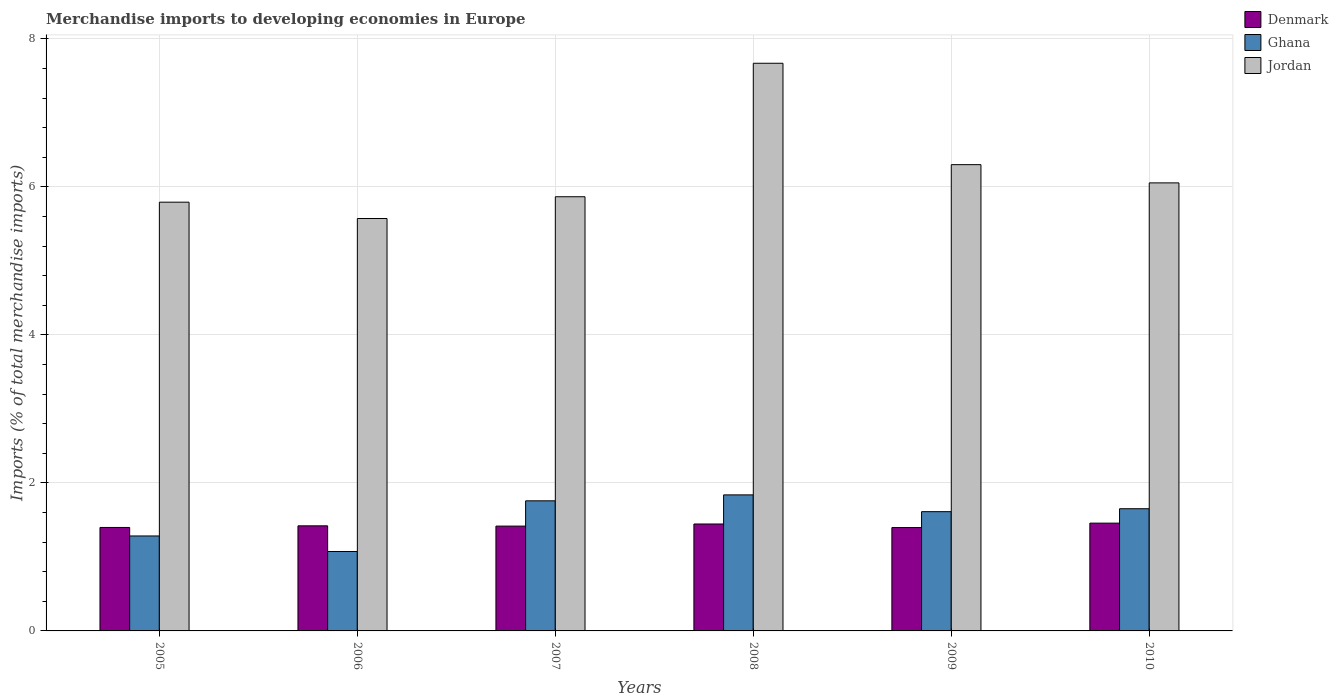How many different coloured bars are there?
Offer a very short reply. 3. How many groups of bars are there?
Provide a succinct answer. 6. In how many cases, is the number of bars for a given year not equal to the number of legend labels?
Ensure brevity in your answer.  0. What is the percentage total merchandise imports in Ghana in 2007?
Ensure brevity in your answer.  1.76. Across all years, what is the maximum percentage total merchandise imports in Denmark?
Provide a succinct answer. 1.46. Across all years, what is the minimum percentage total merchandise imports in Jordan?
Ensure brevity in your answer.  5.57. In which year was the percentage total merchandise imports in Ghana maximum?
Provide a short and direct response. 2008. What is the total percentage total merchandise imports in Jordan in the graph?
Your answer should be compact. 37.26. What is the difference between the percentage total merchandise imports in Denmark in 2006 and that in 2009?
Offer a terse response. 0.02. What is the difference between the percentage total merchandise imports in Jordan in 2007 and the percentage total merchandise imports in Denmark in 2009?
Give a very brief answer. 4.47. What is the average percentage total merchandise imports in Denmark per year?
Provide a succinct answer. 1.42. In the year 2006, what is the difference between the percentage total merchandise imports in Jordan and percentage total merchandise imports in Denmark?
Your answer should be compact. 4.15. What is the ratio of the percentage total merchandise imports in Denmark in 2007 to that in 2010?
Provide a short and direct response. 0.97. Is the percentage total merchandise imports in Jordan in 2005 less than that in 2010?
Keep it short and to the point. Yes. Is the difference between the percentage total merchandise imports in Jordan in 2009 and 2010 greater than the difference between the percentage total merchandise imports in Denmark in 2009 and 2010?
Offer a terse response. Yes. What is the difference between the highest and the second highest percentage total merchandise imports in Denmark?
Provide a short and direct response. 0.01. What is the difference between the highest and the lowest percentage total merchandise imports in Jordan?
Your answer should be compact. 2.1. In how many years, is the percentage total merchandise imports in Denmark greater than the average percentage total merchandise imports in Denmark taken over all years?
Give a very brief answer. 2. What does the 3rd bar from the left in 2006 represents?
Offer a terse response. Jordan. What does the 1st bar from the right in 2009 represents?
Your response must be concise. Jordan. How many bars are there?
Provide a succinct answer. 18. Are all the bars in the graph horizontal?
Give a very brief answer. No. How many years are there in the graph?
Provide a short and direct response. 6. What is the difference between two consecutive major ticks on the Y-axis?
Offer a terse response. 2. Does the graph contain grids?
Offer a terse response. Yes. Where does the legend appear in the graph?
Your response must be concise. Top right. How are the legend labels stacked?
Provide a short and direct response. Vertical. What is the title of the graph?
Ensure brevity in your answer.  Merchandise imports to developing economies in Europe. Does "Sub-Saharan Africa (all income levels)" appear as one of the legend labels in the graph?
Provide a succinct answer. No. What is the label or title of the Y-axis?
Provide a succinct answer. Imports (% of total merchandise imports). What is the Imports (% of total merchandise imports) in Denmark in 2005?
Your answer should be very brief. 1.4. What is the Imports (% of total merchandise imports) in Ghana in 2005?
Offer a very short reply. 1.28. What is the Imports (% of total merchandise imports) of Jordan in 2005?
Provide a succinct answer. 5.79. What is the Imports (% of total merchandise imports) in Denmark in 2006?
Ensure brevity in your answer.  1.42. What is the Imports (% of total merchandise imports) of Ghana in 2006?
Your answer should be compact. 1.07. What is the Imports (% of total merchandise imports) in Jordan in 2006?
Provide a succinct answer. 5.57. What is the Imports (% of total merchandise imports) in Denmark in 2007?
Make the answer very short. 1.42. What is the Imports (% of total merchandise imports) in Ghana in 2007?
Your answer should be very brief. 1.76. What is the Imports (% of total merchandise imports) in Jordan in 2007?
Give a very brief answer. 5.87. What is the Imports (% of total merchandise imports) in Denmark in 2008?
Keep it short and to the point. 1.44. What is the Imports (% of total merchandise imports) of Ghana in 2008?
Provide a succinct answer. 1.84. What is the Imports (% of total merchandise imports) of Jordan in 2008?
Ensure brevity in your answer.  7.67. What is the Imports (% of total merchandise imports) in Denmark in 2009?
Give a very brief answer. 1.4. What is the Imports (% of total merchandise imports) of Ghana in 2009?
Keep it short and to the point. 1.61. What is the Imports (% of total merchandise imports) of Jordan in 2009?
Ensure brevity in your answer.  6.3. What is the Imports (% of total merchandise imports) in Denmark in 2010?
Give a very brief answer. 1.46. What is the Imports (% of total merchandise imports) of Ghana in 2010?
Your answer should be very brief. 1.65. What is the Imports (% of total merchandise imports) in Jordan in 2010?
Your answer should be compact. 6.05. Across all years, what is the maximum Imports (% of total merchandise imports) of Denmark?
Provide a short and direct response. 1.46. Across all years, what is the maximum Imports (% of total merchandise imports) of Ghana?
Keep it short and to the point. 1.84. Across all years, what is the maximum Imports (% of total merchandise imports) of Jordan?
Keep it short and to the point. 7.67. Across all years, what is the minimum Imports (% of total merchandise imports) of Denmark?
Offer a very short reply. 1.4. Across all years, what is the minimum Imports (% of total merchandise imports) in Ghana?
Provide a short and direct response. 1.07. Across all years, what is the minimum Imports (% of total merchandise imports) of Jordan?
Provide a short and direct response. 5.57. What is the total Imports (% of total merchandise imports) in Denmark in the graph?
Provide a succinct answer. 8.53. What is the total Imports (% of total merchandise imports) in Ghana in the graph?
Offer a very short reply. 9.22. What is the total Imports (% of total merchandise imports) in Jordan in the graph?
Your answer should be very brief. 37.26. What is the difference between the Imports (% of total merchandise imports) of Denmark in 2005 and that in 2006?
Provide a succinct answer. -0.02. What is the difference between the Imports (% of total merchandise imports) in Ghana in 2005 and that in 2006?
Provide a succinct answer. 0.21. What is the difference between the Imports (% of total merchandise imports) in Jordan in 2005 and that in 2006?
Make the answer very short. 0.22. What is the difference between the Imports (% of total merchandise imports) in Denmark in 2005 and that in 2007?
Ensure brevity in your answer.  -0.02. What is the difference between the Imports (% of total merchandise imports) in Ghana in 2005 and that in 2007?
Your response must be concise. -0.47. What is the difference between the Imports (% of total merchandise imports) of Jordan in 2005 and that in 2007?
Ensure brevity in your answer.  -0.07. What is the difference between the Imports (% of total merchandise imports) in Denmark in 2005 and that in 2008?
Your answer should be compact. -0.05. What is the difference between the Imports (% of total merchandise imports) of Ghana in 2005 and that in 2008?
Give a very brief answer. -0.56. What is the difference between the Imports (% of total merchandise imports) of Jordan in 2005 and that in 2008?
Offer a very short reply. -1.88. What is the difference between the Imports (% of total merchandise imports) of Denmark in 2005 and that in 2009?
Your answer should be very brief. 0. What is the difference between the Imports (% of total merchandise imports) of Ghana in 2005 and that in 2009?
Provide a short and direct response. -0.33. What is the difference between the Imports (% of total merchandise imports) of Jordan in 2005 and that in 2009?
Ensure brevity in your answer.  -0.51. What is the difference between the Imports (% of total merchandise imports) in Denmark in 2005 and that in 2010?
Provide a short and direct response. -0.06. What is the difference between the Imports (% of total merchandise imports) in Ghana in 2005 and that in 2010?
Give a very brief answer. -0.37. What is the difference between the Imports (% of total merchandise imports) of Jordan in 2005 and that in 2010?
Give a very brief answer. -0.26. What is the difference between the Imports (% of total merchandise imports) of Denmark in 2006 and that in 2007?
Make the answer very short. 0. What is the difference between the Imports (% of total merchandise imports) of Ghana in 2006 and that in 2007?
Your answer should be very brief. -0.68. What is the difference between the Imports (% of total merchandise imports) of Jordan in 2006 and that in 2007?
Offer a very short reply. -0.29. What is the difference between the Imports (% of total merchandise imports) in Denmark in 2006 and that in 2008?
Keep it short and to the point. -0.02. What is the difference between the Imports (% of total merchandise imports) in Ghana in 2006 and that in 2008?
Your answer should be compact. -0.77. What is the difference between the Imports (% of total merchandise imports) in Jordan in 2006 and that in 2008?
Your answer should be very brief. -2.1. What is the difference between the Imports (% of total merchandise imports) of Denmark in 2006 and that in 2009?
Give a very brief answer. 0.02. What is the difference between the Imports (% of total merchandise imports) in Ghana in 2006 and that in 2009?
Offer a terse response. -0.54. What is the difference between the Imports (% of total merchandise imports) of Jordan in 2006 and that in 2009?
Offer a very short reply. -0.73. What is the difference between the Imports (% of total merchandise imports) of Denmark in 2006 and that in 2010?
Provide a succinct answer. -0.04. What is the difference between the Imports (% of total merchandise imports) of Ghana in 2006 and that in 2010?
Provide a succinct answer. -0.58. What is the difference between the Imports (% of total merchandise imports) of Jordan in 2006 and that in 2010?
Offer a terse response. -0.48. What is the difference between the Imports (% of total merchandise imports) in Denmark in 2007 and that in 2008?
Your answer should be very brief. -0.03. What is the difference between the Imports (% of total merchandise imports) in Ghana in 2007 and that in 2008?
Offer a terse response. -0.08. What is the difference between the Imports (% of total merchandise imports) in Jordan in 2007 and that in 2008?
Your answer should be compact. -1.8. What is the difference between the Imports (% of total merchandise imports) of Denmark in 2007 and that in 2009?
Offer a terse response. 0.02. What is the difference between the Imports (% of total merchandise imports) of Ghana in 2007 and that in 2009?
Provide a short and direct response. 0.15. What is the difference between the Imports (% of total merchandise imports) in Jordan in 2007 and that in 2009?
Keep it short and to the point. -0.43. What is the difference between the Imports (% of total merchandise imports) of Denmark in 2007 and that in 2010?
Offer a very short reply. -0.04. What is the difference between the Imports (% of total merchandise imports) in Ghana in 2007 and that in 2010?
Give a very brief answer. 0.11. What is the difference between the Imports (% of total merchandise imports) of Jordan in 2007 and that in 2010?
Keep it short and to the point. -0.19. What is the difference between the Imports (% of total merchandise imports) in Denmark in 2008 and that in 2009?
Give a very brief answer. 0.05. What is the difference between the Imports (% of total merchandise imports) of Ghana in 2008 and that in 2009?
Provide a short and direct response. 0.23. What is the difference between the Imports (% of total merchandise imports) of Jordan in 2008 and that in 2009?
Keep it short and to the point. 1.37. What is the difference between the Imports (% of total merchandise imports) in Denmark in 2008 and that in 2010?
Your response must be concise. -0.01. What is the difference between the Imports (% of total merchandise imports) in Ghana in 2008 and that in 2010?
Your response must be concise. 0.19. What is the difference between the Imports (% of total merchandise imports) in Jordan in 2008 and that in 2010?
Your answer should be compact. 1.62. What is the difference between the Imports (% of total merchandise imports) in Denmark in 2009 and that in 2010?
Ensure brevity in your answer.  -0.06. What is the difference between the Imports (% of total merchandise imports) in Ghana in 2009 and that in 2010?
Ensure brevity in your answer.  -0.04. What is the difference between the Imports (% of total merchandise imports) in Jordan in 2009 and that in 2010?
Your answer should be compact. 0.25. What is the difference between the Imports (% of total merchandise imports) of Denmark in 2005 and the Imports (% of total merchandise imports) of Ghana in 2006?
Give a very brief answer. 0.32. What is the difference between the Imports (% of total merchandise imports) of Denmark in 2005 and the Imports (% of total merchandise imports) of Jordan in 2006?
Provide a short and direct response. -4.17. What is the difference between the Imports (% of total merchandise imports) in Ghana in 2005 and the Imports (% of total merchandise imports) in Jordan in 2006?
Offer a terse response. -4.29. What is the difference between the Imports (% of total merchandise imports) of Denmark in 2005 and the Imports (% of total merchandise imports) of Ghana in 2007?
Keep it short and to the point. -0.36. What is the difference between the Imports (% of total merchandise imports) of Denmark in 2005 and the Imports (% of total merchandise imports) of Jordan in 2007?
Ensure brevity in your answer.  -4.47. What is the difference between the Imports (% of total merchandise imports) of Ghana in 2005 and the Imports (% of total merchandise imports) of Jordan in 2007?
Keep it short and to the point. -4.58. What is the difference between the Imports (% of total merchandise imports) of Denmark in 2005 and the Imports (% of total merchandise imports) of Ghana in 2008?
Your answer should be compact. -0.44. What is the difference between the Imports (% of total merchandise imports) of Denmark in 2005 and the Imports (% of total merchandise imports) of Jordan in 2008?
Offer a very short reply. -6.27. What is the difference between the Imports (% of total merchandise imports) in Ghana in 2005 and the Imports (% of total merchandise imports) in Jordan in 2008?
Give a very brief answer. -6.39. What is the difference between the Imports (% of total merchandise imports) in Denmark in 2005 and the Imports (% of total merchandise imports) in Ghana in 2009?
Offer a very short reply. -0.21. What is the difference between the Imports (% of total merchandise imports) in Denmark in 2005 and the Imports (% of total merchandise imports) in Jordan in 2009?
Give a very brief answer. -4.9. What is the difference between the Imports (% of total merchandise imports) in Ghana in 2005 and the Imports (% of total merchandise imports) in Jordan in 2009?
Offer a very short reply. -5.02. What is the difference between the Imports (% of total merchandise imports) of Denmark in 2005 and the Imports (% of total merchandise imports) of Ghana in 2010?
Provide a short and direct response. -0.25. What is the difference between the Imports (% of total merchandise imports) of Denmark in 2005 and the Imports (% of total merchandise imports) of Jordan in 2010?
Keep it short and to the point. -4.66. What is the difference between the Imports (% of total merchandise imports) in Ghana in 2005 and the Imports (% of total merchandise imports) in Jordan in 2010?
Keep it short and to the point. -4.77. What is the difference between the Imports (% of total merchandise imports) of Denmark in 2006 and the Imports (% of total merchandise imports) of Ghana in 2007?
Offer a very short reply. -0.34. What is the difference between the Imports (% of total merchandise imports) of Denmark in 2006 and the Imports (% of total merchandise imports) of Jordan in 2007?
Offer a very short reply. -4.45. What is the difference between the Imports (% of total merchandise imports) in Ghana in 2006 and the Imports (% of total merchandise imports) in Jordan in 2007?
Provide a succinct answer. -4.79. What is the difference between the Imports (% of total merchandise imports) of Denmark in 2006 and the Imports (% of total merchandise imports) of Ghana in 2008?
Offer a terse response. -0.42. What is the difference between the Imports (% of total merchandise imports) in Denmark in 2006 and the Imports (% of total merchandise imports) in Jordan in 2008?
Your answer should be very brief. -6.25. What is the difference between the Imports (% of total merchandise imports) of Ghana in 2006 and the Imports (% of total merchandise imports) of Jordan in 2008?
Give a very brief answer. -6.6. What is the difference between the Imports (% of total merchandise imports) of Denmark in 2006 and the Imports (% of total merchandise imports) of Ghana in 2009?
Provide a short and direct response. -0.19. What is the difference between the Imports (% of total merchandise imports) of Denmark in 2006 and the Imports (% of total merchandise imports) of Jordan in 2009?
Your answer should be very brief. -4.88. What is the difference between the Imports (% of total merchandise imports) in Ghana in 2006 and the Imports (% of total merchandise imports) in Jordan in 2009?
Offer a terse response. -5.23. What is the difference between the Imports (% of total merchandise imports) of Denmark in 2006 and the Imports (% of total merchandise imports) of Ghana in 2010?
Offer a terse response. -0.23. What is the difference between the Imports (% of total merchandise imports) in Denmark in 2006 and the Imports (% of total merchandise imports) in Jordan in 2010?
Your answer should be very brief. -4.63. What is the difference between the Imports (% of total merchandise imports) of Ghana in 2006 and the Imports (% of total merchandise imports) of Jordan in 2010?
Offer a terse response. -4.98. What is the difference between the Imports (% of total merchandise imports) of Denmark in 2007 and the Imports (% of total merchandise imports) of Ghana in 2008?
Provide a short and direct response. -0.42. What is the difference between the Imports (% of total merchandise imports) of Denmark in 2007 and the Imports (% of total merchandise imports) of Jordan in 2008?
Keep it short and to the point. -6.25. What is the difference between the Imports (% of total merchandise imports) of Ghana in 2007 and the Imports (% of total merchandise imports) of Jordan in 2008?
Provide a succinct answer. -5.91. What is the difference between the Imports (% of total merchandise imports) in Denmark in 2007 and the Imports (% of total merchandise imports) in Ghana in 2009?
Provide a succinct answer. -0.2. What is the difference between the Imports (% of total merchandise imports) of Denmark in 2007 and the Imports (% of total merchandise imports) of Jordan in 2009?
Offer a terse response. -4.88. What is the difference between the Imports (% of total merchandise imports) in Ghana in 2007 and the Imports (% of total merchandise imports) in Jordan in 2009?
Your response must be concise. -4.54. What is the difference between the Imports (% of total merchandise imports) of Denmark in 2007 and the Imports (% of total merchandise imports) of Ghana in 2010?
Provide a succinct answer. -0.23. What is the difference between the Imports (% of total merchandise imports) of Denmark in 2007 and the Imports (% of total merchandise imports) of Jordan in 2010?
Offer a very short reply. -4.64. What is the difference between the Imports (% of total merchandise imports) in Ghana in 2007 and the Imports (% of total merchandise imports) in Jordan in 2010?
Offer a terse response. -4.3. What is the difference between the Imports (% of total merchandise imports) of Denmark in 2008 and the Imports (% of total merchandise imports) of Ghana in 2009?
Your answer should be very brief. -0.17. What is the difference between the Imports (% of total merchandise imports) in Denmark in 2008 and the Imports (% of total merchandise imports) in Jordan in 2009?
Your response must be concise. -4.86. What is the difference between the Imports (% of total merchandise imports) of Ghana in 2008 and the Imports (% of total merchandise imports) of Jordan in 2009?
Your answer should be compact. -4.46. What is the difference between the Imports (% of total merchandise imports) of Denmark in 2008 and the Imports (% of total merchandise imports) of Ghana in 2010?
Ensure brevity in your answer.  -0.21. What is the difference between the Imports (% of total merchandise imports) of Denmark in 2008 and the Imports (% of total merchandise imports) of Jordan in 2010?
Provide a succinct answer. -4.61. What is the difference between the Imports (% of total merchandise imports) of Ghana in 2008 and the Imports (% of total merchandise imports) of Jordan in 2010?
Offer a terse response. -4.22. What is the difference between the Imports (% of total merchandise imports) of Denmark in 2009 and the Imports (% of total merchandise imports) of Ghana in 2010?
Give a very brief answer. -0.25. What is the difference between the Imports (% of total merchandise imports) in Denmark in 2009 and the Imports (% of total merchandise imports) in Jordan in 2010?
Give a very brief answer. -4.66. What is the difference between the Imports (% of total merchandise imports) in Ghana in 2009 and the Imports (% of total merchandise imports) in Jordan in 2010?
Your answer should be compact. -4.44. What is the average Imports (% of total merchandise imports) in Denmark per year?
Give a very brief answer. 1.42. What is the average Imports (% of total merchandise imports) of Ghana per year?
Make the answer very short. 1.54. What is the average Imports (% of total merchandise imports) in Jordan per year?
Ensure brevity in your answer.  6.21. In the year 2005, what is the difference between the Imports (% of total merchandise imports) of Denmark and Imports (% of total merchandise imports) of Ghana?
Offer a terse response. 0.11. In the year 2005, what is the difference between the Imports (% of total merchandise imports) of Denmark and Imports (% of total merchandise imports) of Jordan?
Offer a very short reply. -4.4. In the year 2005, what is the difference between the Imports (% of total merchandise imports) of Ghana and Imports (% of total merchandise imports) of Jordan?
Your response must be concise. -4.51. In the year 2006, what is the difference between the Imports (% of total merchandise imports) of Denmark and Imports (% of total merchandise imports) of Ghana?
Ensure brevity in your answer.  0.35. In the year 2006, what is the difference between the Imports (% of total merchandise imports) in Denmark and Imports (% of total merchandise imports) in Jordan?
Provide a succinct answer. -4.15. In the year 2006, what is the difference between the Imports (% of total merchandise imports) in Ghana and Imports (% of total merchandise imports) in Jordan?
Your answer should be very brief. -4.5. In the year 2007, what is the difference between the Imports (% of total merchandise imports) of Denmark and Imports (% of total merchandise imports) of Ghana?
Provide a succinct answer. -0.34. In the year 2007, what is the difference between the Imports (% of total merchandise imports) in Denmark and Imports (% of total merchandise imports) in Jordan?
Keep it short and to the point. -4.45. In the year 2007, what is the difference between the Imports (% of total merchandise imports) in Ghana and Imports (% of total merchandise imports) in Jordan?
Offer a very short reply. -4.11. In the year 2008, what is the difference between the Imports (% of total merchandise imports) of Denmark and Imports (% of total merchandise imports) of Ghana?
Your answer should be compact. -0.39. In the year 2008, what is the difference between the Imports (% of total merchandise imports) of Denmark and Imports (% of total merchandise imports) of Jordan?
Your answer should be very brief. -6.23. In the year 2008, what is the difference between the Imports (% of total merchandise imports) in Ghana and Imports (% of total merchandise imports) in Jordan?
Offer a very short reply. -5.83. In the year 2009, what is the difference between the Imports (% of total merchandise imports) of Denmark and Imports (% of total merchandise imports) of Ghana?
Your answer should be very brief. -0.21. In the year 2009, what is the difference between the Imports (% of total merchandise imports) in Denmark and Imports (% of total merchandise imports) in Jordan?
Make the answer very short. -4.9. In the year 2009, what is the difference between the Imports (% of total merchandise imports) of Ghana and Imports (% of total merchandise imports) of Jordan?
Your answer should be very brief. -4.69. In the year 2010, what is the difference between the Imports (% of total merchandise imports) in Denmark and Imports (% of total merchandise imports) in Ghana?
Offer a terse response. -0.19. In the year 2010, what is the difference between the Imports (% of total merchandise imports) of Denmark and Imports (% of total merchandise imports) of Jordan?
Provide a succinct answer. -4.6. In the year 2010, what is the difference between the Imports (% of total merchandise imports) in Ghana and Imports (% of total merchandise imports) in Jordan?
Your response must be concise. -4.4. What is the ratio of the Imports (% of total merchandise imports) of Denmark in 2005 to that in 2006?
Your response must be concise. 0.98. What is the ratio of the Imports (% of total merchandise imports) of Ghana in 2005 to that in 2006?
Provide a succinct answer. 1.2. What is the ratio of the Imports (% of total merchandise imports) of Jordan in 2005 to that in 2006?
Give a very brief answer. 1.04. What is the ratio of the Imports (% of total merchandise imports) in Denmark in 2005 to that in 2007?
Offer a terse response. 0.99. What is the ratio of the Imports (% of total merchandise imports) of Ghana in 2005 to that in 2007?
Keep it short and to the point. 0.73. What is the ratio of the Imports (% of total merchandise imports) in Jordan in 2005 to that in 2007?
Keep it short and to the point. 0.99. What is the ratio of the Imports (% of total merchandise imports) of Denmark in 2005 to that in 2008?
Offer a terse response. 0.97. What is the ratio of the Imports (% of total merchandise imports) of Ghana in 2005 to that in 2008?
Offer a very short reply. 0.7. What is the ratio of the Imports (% of total merchandise imports) in Jordan in 2005 to that in 2008?
Offer a very short reply. 0.76. What is the ratio of the Imports (% of total merchandise imports) of Ghana in 2005 to that in 2009?
Keep it short and to the point. 0.8. What is the ratio of the Imports (% of total merchandise imports) of Jordan in 2005 to that in 2009?
Offer a very short reply. 0.92. What is the ratio of the Imports (% of total merchandise imports) in Denmark in 2005 to that in 2010?
Provide a succinct answer. 0.96. What is the ratio of the Imports (% of total merchandise imports) of Ghana in 2005 to that in 2010?
Provide a succinct answer. 0.78. What is the ratio of the Imports (% of total merchandise imports) in Jordan in 2005 to that in 2010?
Your response must be concise. 0.96. What is the ratio of the Imports (% of total merchandise imports) in Denmark in 2006 to that in 2007?
Ensure brevity in your answer.  1. What is the ratio of the Imports (% of total merchandise imports) in Ghana in 2006 to that in 2007?
Offer a terse response. 0.61. What is the ratio of the Imports (% of total merchandise imports) in Jordan in 2006 to that in 2007?
Offer a terse response. 0.95. What is the ratio of the Imports (% of total merchandise imports) of Denmark in 2006 to that in 2008?
Ensure brevity in your answer.  0.98. What is the ratio of the Imports (% of total merchandise imports) of Ghana in 2006 to that in 2008?
Your answer should be compact. 0.58. What is the ratio of the Imports (% of total merchandise imports) of Jordan in 2006 to that in 2008?
Your answer should be compact. 0.73. What is the ratio of the Imports (% of total merchandise imports) in Denmark in 2006 to that in 2009?
Keep it short and to the point. 1.02. What is the ratio of the Imports (% of total merchandise imports) in Ghana in 2006 to that in 2009?
Give a very brief answer. 0.67. What is the ratio of the Imports (% of total merchandise imports) in Jordan in 2006 to that in 2009?
Give a very brief answer. 0.88. What is the ratio of the Imports (% of total merchandise imports) of Ghana in 2006 to that in 2010?
Offer a terse response. 0.65. What is the ratio of the Imports (% of total merchandise imports) in Jordan in 2006 to that in 2010?
Give a very brief answer. 0.92. What is the ratio of the Imports (% of total merchandise imports) in Denmark in 2007 to that in 2008?
Make the answer very short. 0.98. What is the ratio of the Imports (% of total merchandise imports) in Ghana in 2007 to that in 2008?
Offer a very short reply. 0.96. What is the ratio of the Imports (% of total merchandise imports) in Jordan in 2007 to that in 2008?
Your answer should be very brief. 0.76. What is the ratio of the Imports (% of total merchandise imports) of Denmark in 2007 to that in 2009?
Your answer should be compact. 1.01. What is the ratio of the Imports (% of total merchandise imports) in Ghana in 2007 to that in 2009?
Make the answer very short. 1.09. What is the ratio of the Imports (% of total merchandise imports) in Jordan in 2007 to that in 2009?
Provide a succinct answer. 0.93. What is the ratio of the Imports (% of total merchandise imports) in Denmark in 2007 to that in 2010?
Offer a very short reply. 0.97. What is the ratio of the Imports (% of total merchandise imports) in Ghana in 2007 to that in 2010?
Your response must be concise. 1.06. What is the ratio of the Imports (% of total merchandise imports) in Jordan in 2007 to that in 2010?
Your response must be concise. 0.97. What is the ratio of the Imports (% of total merchandise imports) in Denmark in 2008 to that in 2009?
Offer a very short reply. 1.03. What is the ratio of the Imports (% of total merchandise imports) of Ghana in 2008 to that in 2009?
Make the answer very short. 1.14. What is the ratio of the Imports (% of total merchandise imports) of Jordan in 2008 to that in 2009?
Your answer should be compact. 1.22. What is the ratio of the Imports (% of total merchandise imports) of Ghana in 2008 to that in 2010?
Provide a short and direct response. 1.11. What is the ratio of the Imports (% of total merchandise imports) in Jordan in 2008 to that in 2010?
Offer a terse response. 1.27. What is the ratio of the Imports (% of total merchandise imports) in Ghana in 2009 to that in 2010?
Offer a terse response. 0.98. What is the ratio of the Imports (% of total merchandise imports) in Jordan in 2009 to that in 2010?
Your response must be concise. 1.04. What is the difference between the highest and the second highest Imports (% of total merchandise imports) in Denmark?
Provide a short and direct response. 0.01. What is the difference between the highest and the second highest Imports (% of total merchandise imports) in Ghana?
Provide a short and direct response. 0.08. What is the difference between the highest and the second highest Imports (% of total merchandise imports) in Jordan?
Keep it short and to the point. 1.37. What is the difference between the highest and the lowest Imports (% of total merchandise imports) in Denmark?
Your answer should be very brief. 0.06. What is the difference between the highest and the lowest Imports (% of total merchandise imports) of Ghana?
Your response must be concise. 0.77. What is the difference between the highest and the lowest Imports (% of total merchandise imports) in Jordan?
Provide a short and direct response. 2.1. 